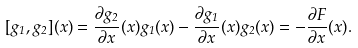<formula> <loc_0><loc_0><loc_500><loc_500>[ g _ { 1 } , g _ { 2 } ] ( x ) = \frac { \partial g _ { 2 } } { \partial x } ( x ) g _ { 1 } ( x ) - \frac { \partial g _ { 1 } } { \partial x } ( x ) g _ { 2 } ( x ) = - \frac { \partial F } { \partial x } ( x ) .</formula> 